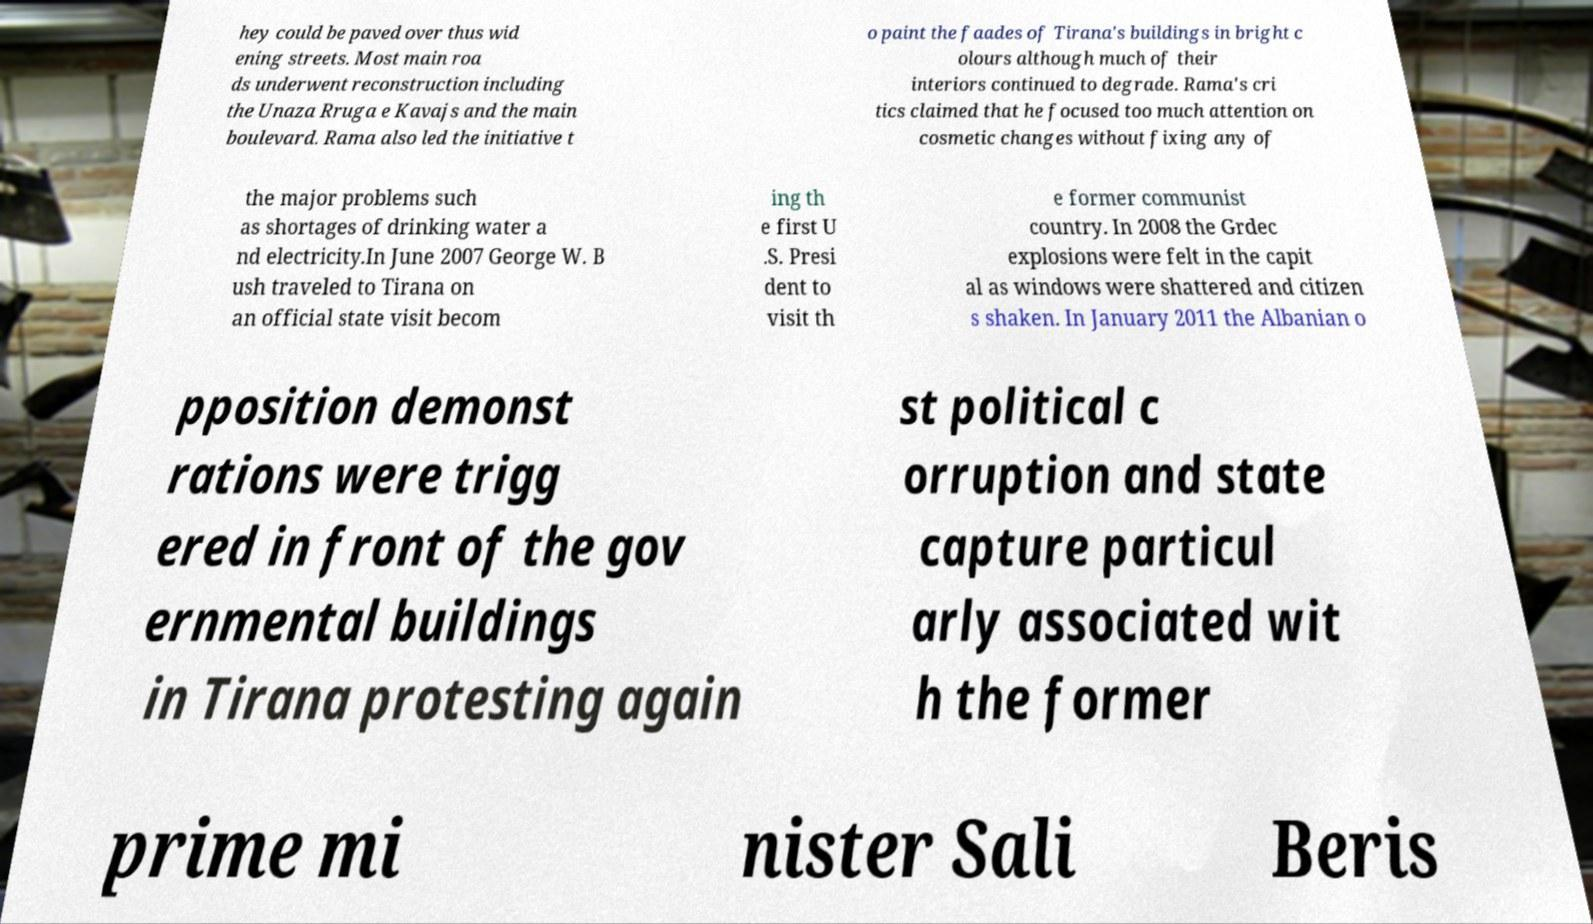Please identify and transcribe the text found in this image. hey could be paved over thus wid ening streets. Most main roa ds underwent reconstruction including the Unaza Rruga e Kavajs and the main boulevard. Rama also led the initiative t o paint the faades of Tirana's buildings in bright c olours although much of their interiors continued to degrade. Rama's cri tics claimed that he focused too much attention on cosmetic changes without fixing any of the major problems such as shortages of drinking water a nd electricity.In June 2007 George W. B ush traveled to Tirana on an official state visit becom ing th e first U .S. Presi dent to visit th e former communist country. In 2008 the Grdec explosions were felt in the capit al as windows were shattered and citizen s shaken. In January 2011 the Albanian o pposition demonst rations were trigg ered in front of the gov ernmental buildings in Tirana protesting again st political c orruption and state capture particul arly associated wit h the former prime mi nister Sali Beris 